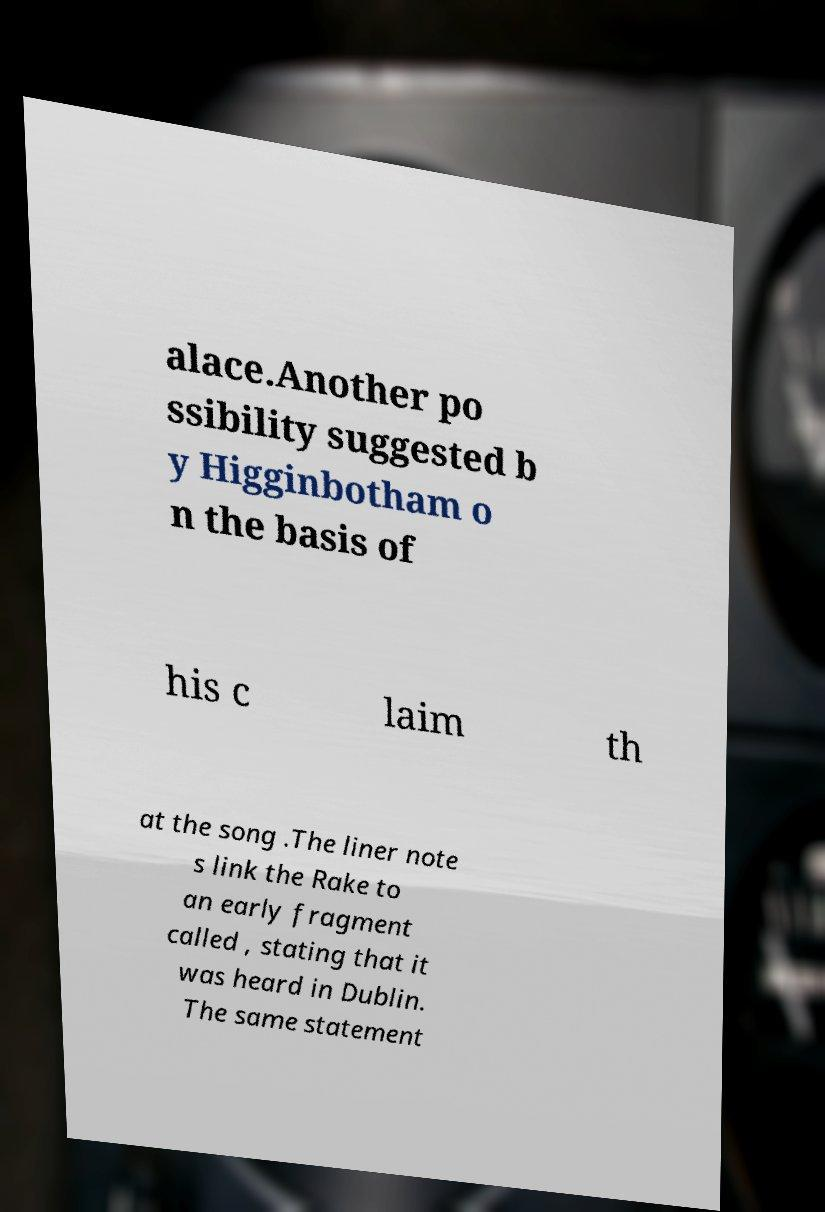There's text embedded in this image that I need extracted. Can you transcribe it verbatim? alace.Another po ssibility suggested b y Higginbotham o n the basis of his c laim th at the song .The liner note s link the Rake to an early fragment called , stating that it was heard in Dublin. The same statement 